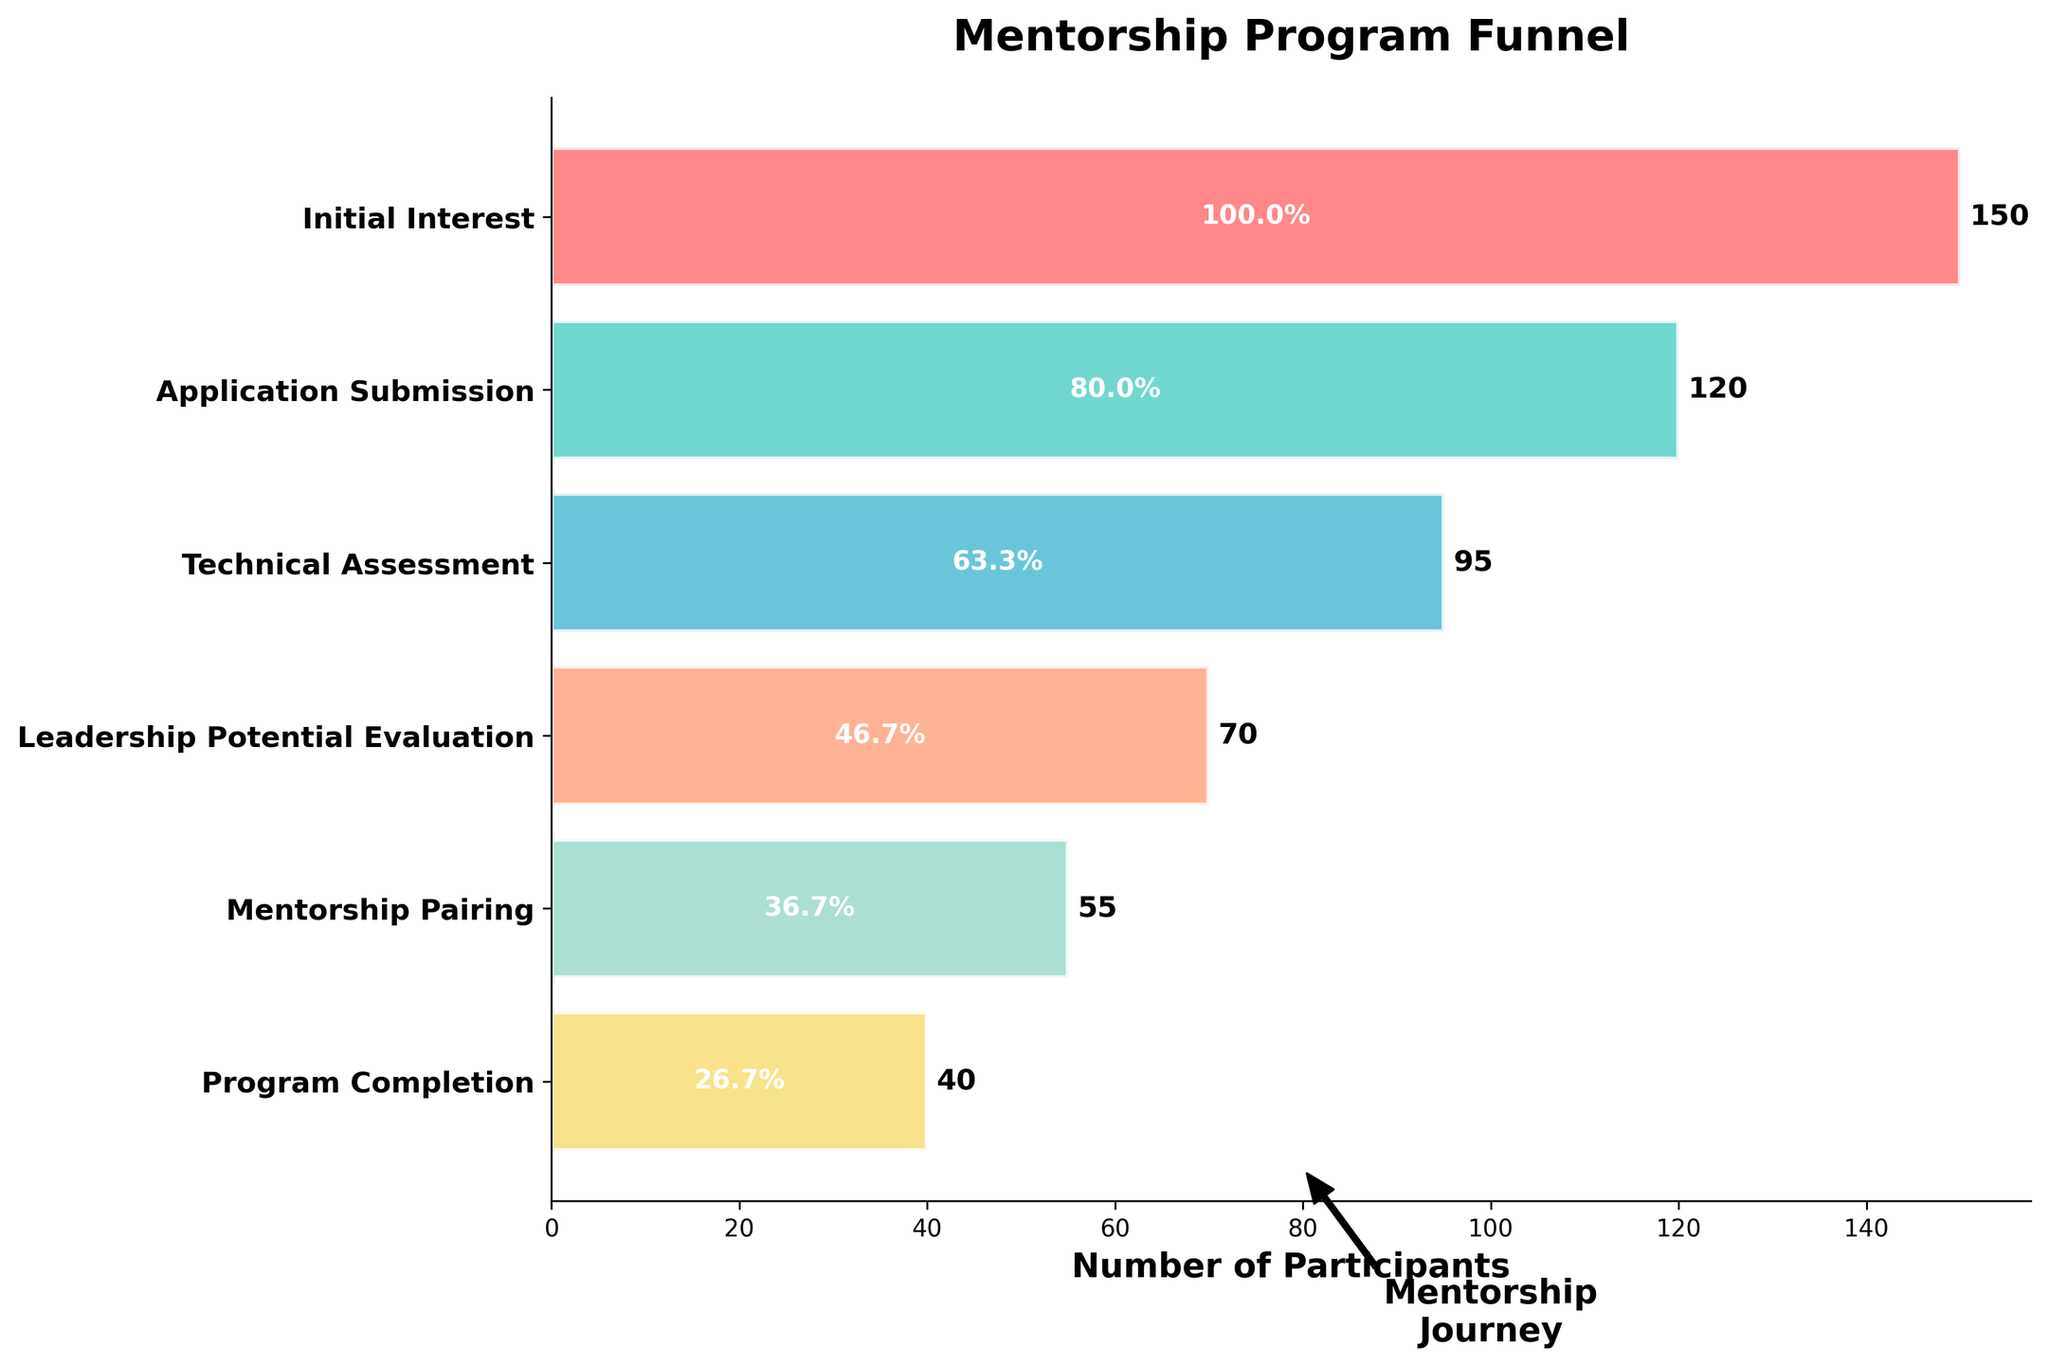What is the title of the funnel chart? The title of the funnel chart is displayed at the top of the plot in bold font.
Answer: 'Mentorship Program Funnel' How many stages are there in the mentorship program funnel? The vertical axis of the chart lists all the stages. Count the number of different stages.
Answer: 6 What color is used for the 'Leadership Potential Evaluation' stage? Each stage has a unique color in the funnel chart. Identify the color associated with 'Leadership Potential Evaluation.'
Answer: '#FFA07A' (a shade of orange) What percentage of participants completed the 'Technical Assessment' stage? Look for the percentage label within the bar corresponding to the 'Technical Assessment' stage.
Answer: 63.3% How many participants moved from 'Application Submission' to 'Technical Assessment'? Subtract the number of participants in the 'Technical Assessment' stage from those in the 'Application Submission' stage.
Answer: 25 participants What is the average number of participants across all stages? Sum the number of participants in all stages and divide by the total number of stages. Calculation: (150 + 120 + 95 + 70 + 55 + 40) / 6
Answer: 88.3 participants Which stage has the highest drop-off in the number of participants, and what is the difference in participants? Look for the largest drop in participants between consecutive stages. Subtract the number of participants of the subsequent stage from the current stage to find the difference.
Answer: 'Initial Interest to Application Submission' with a drop-off of 30 participants How does the number of participants at 'Mentorship Pairing' compare to 'Program Completion'? Compare the number of participants at the 'Mentorship Pairing' stage and the 'Program Completion' stage.
Answer: 'Mentorship Pairing' has 15 more participants than 'Program Completion' What is the percentage drop from 'Initial Interest' to 'Program Completion'? Calculate the percentage drop by subtracting the number at 'Program Completion' from 'Initial Interest,' then divide by 'Initial Interest' and multiply by 100. Calculation: ((150 - 40) / 150) * 100
Answer: 73.3% What does the annotation with the arrow pointing to the funnel signify? The annotation reads 'Mentorship Journey,' emphasizing the progression through the stages of the mentorship program.
Answer: 'Mentorship Journey' 